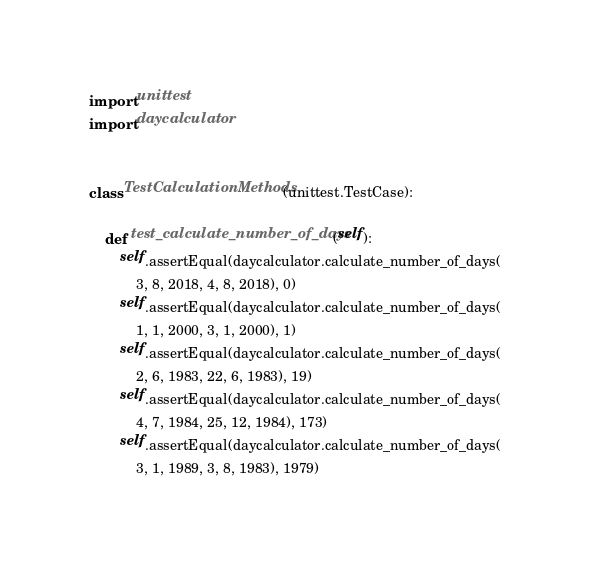Convert code to text. <code><loc_0><loc_0><loc_500><loc_500><_Python_>import unittest
import daycalculator


class TestCalculationMethods(unittest.TestCase):

    def test_calculate_number_of_days(self):
        self.assertEqual(daycalculator.calculate_number_of_days(
            3, 8, 2018, 4, 8, 2018), 0)
        self.assertEqual(daycalculator.calculate_number_of_days(
            1, 1, 2000, 3, 1, 2000), 1)
        self.assertEqual(daycalculator.calculate_number_of_days(
            2, 6, 1983, 22, 6, 1983), 19)
        self.assertEqual(daycalculator.calculate_number_of_days(
            4, 7, 1984, 25, 12, 1984), 173)
        self.assertEqual(daycalculator.calculate_number_of_days(
            3, 1, 1989, 3, 8, 1983), 1979)
</code> 